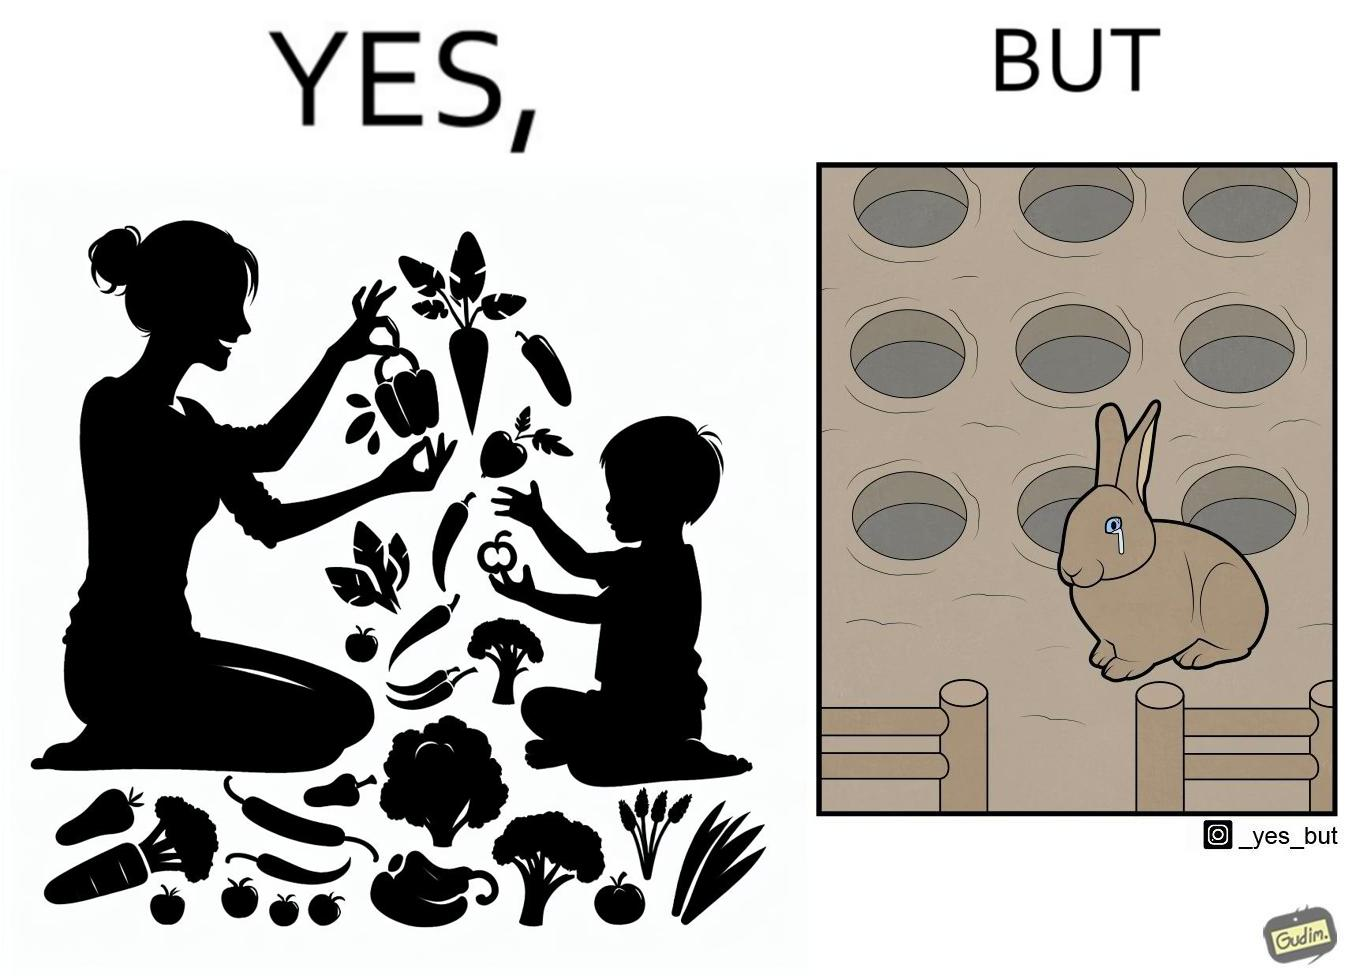Describe what you see in this image. The images are ironic since they show how on one hand humans choose to play with and waste foods like vegetables while the animals are unable to eat enough food and end up starving due to lack of food 